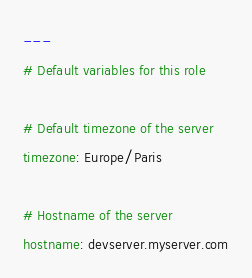<code> <loc_0><loc_0><loc_500><loc_500><_YAML_>---
# Default variables for this role

# Default timezone of the server
timezone: Europe/Paris

# Hostname of the server
hostname: devserver.myserver.com
</code> 